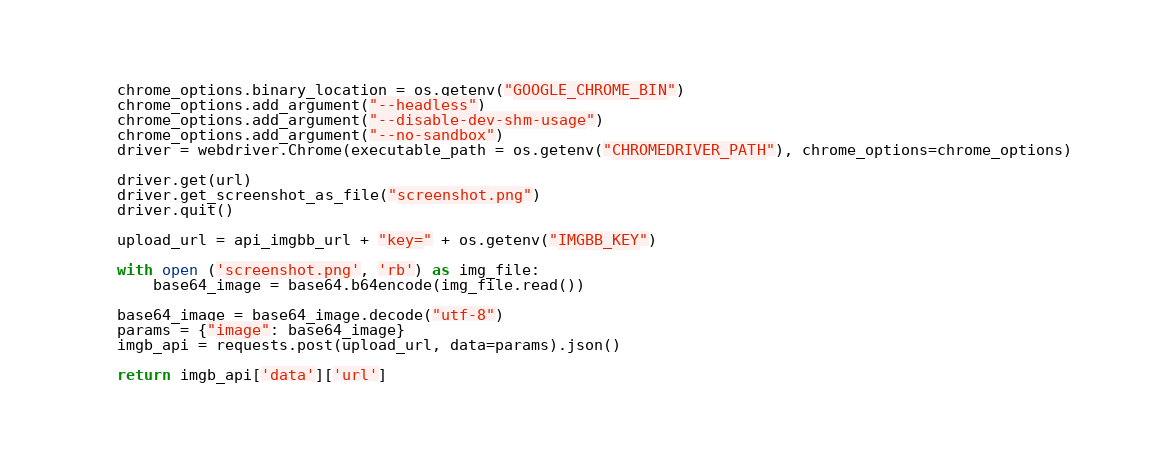<code> <loc_0><loc_0><loc_500><loc_500><_Python_>    chrome_options.binary_location = os.getenv("GOOGLE_CHROME_BIN")
    chrome_options.add_argument("--headless")
    chrome_options.add_argument("--disable-dev-shm-usage")
    chrome_options.add_argument("--no-sandbox")
    driver = webdriver.Chrome(executable_path = os.getenv("CHROMEDRIVER_PATH"), chrome_options=chrome_options)

    driver.get(url)
    driver.get_screenshot_as_file("screenshot.png")
    driver.quit()

    upload_url = api_imgbb_url + "key=" + os.getenv("IMGBB_KEY")

    with open ('screenshot.png', 'rb') as img_file:
        base64_image = base64.b64encode(img_file.read())

    base64_image = base64_image.decode("utf-8")
    params = {"image": base64_image}
    imgb_api = requests.post(upload_url, data=params).json()
    
    return imgb_api['data']['url']
</code> 